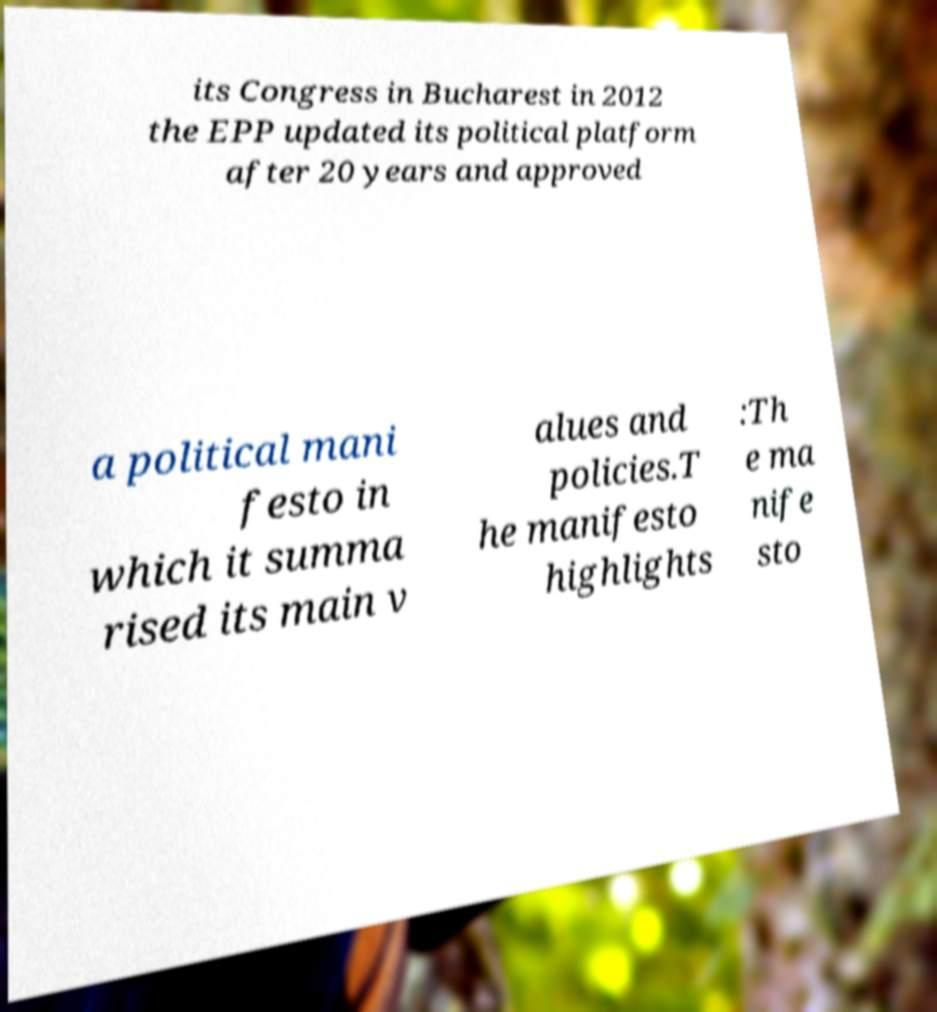Can you read and provide the text displayed in the image?This photo seems to have some interesting text. Can you extract and type it out for me? its Congress in Bucharest in 2012 the EPP updated its political platform after 20 years and approved a political mani festo in which it summa rised its main v alues and policies.T he manifesto highlights :Th e ma nife sto 